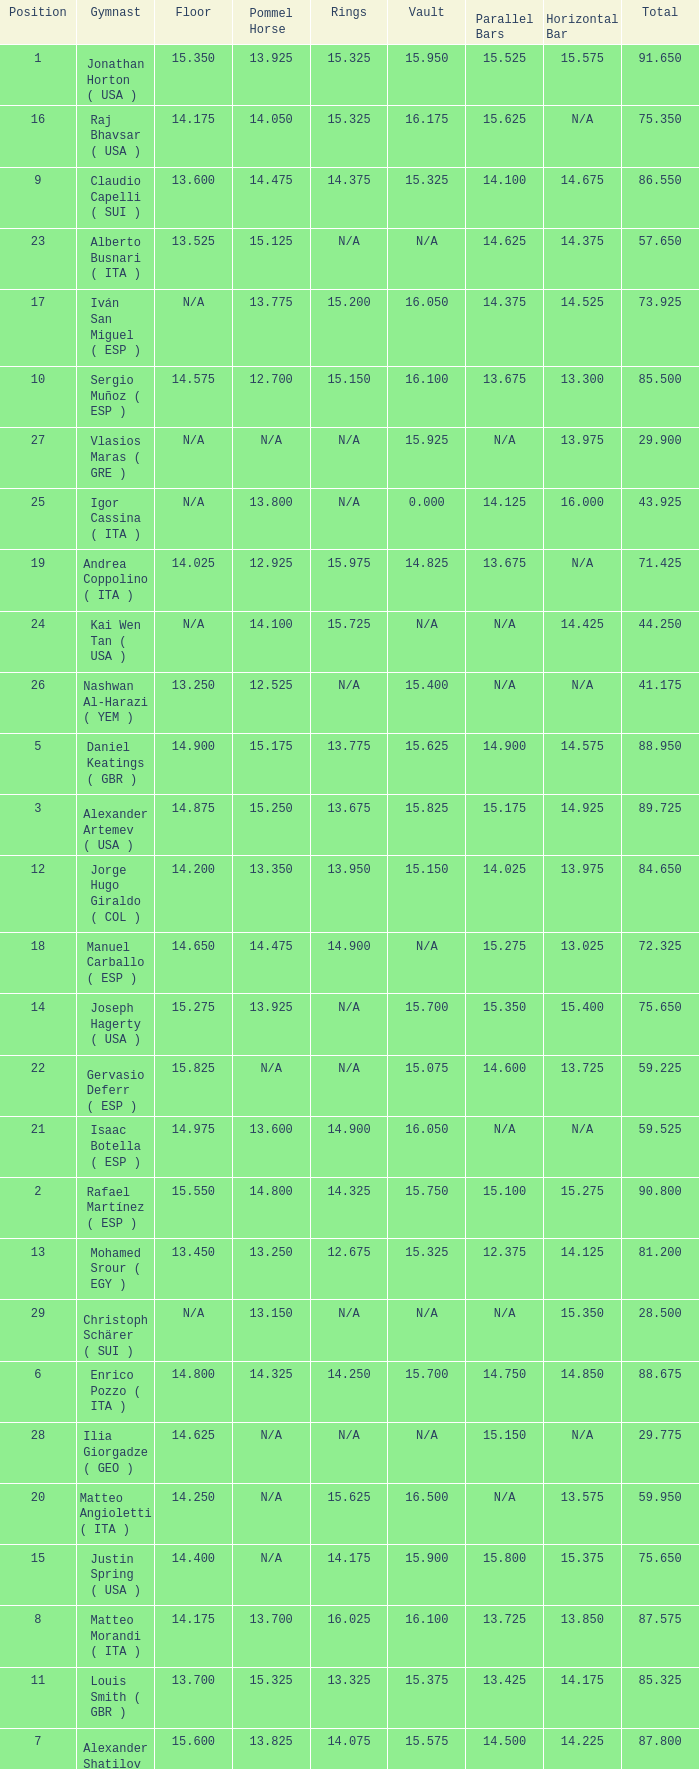If the floor number is 14.200, what is the number for the parallel bars? 14.025. 